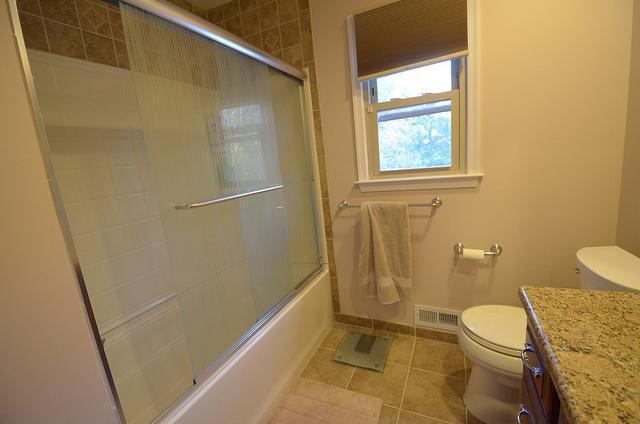How many towels in this photo?
Give a very brief answer. 1. 